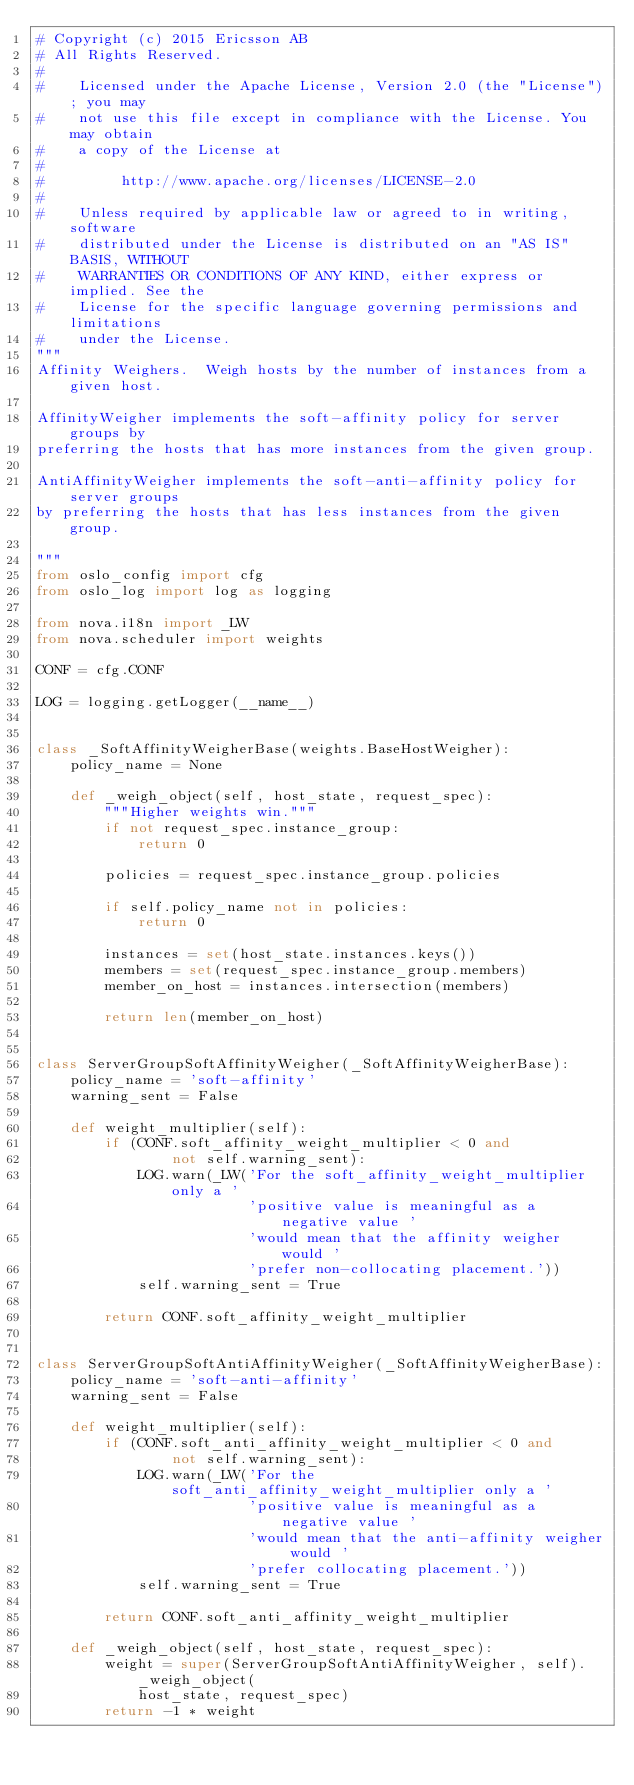<code> <loc_0><loc_0><loc_500><loc_500><_Python_># Copyright (c) 2015 Ericsson AB
# All Rights Reserved.
#
#    Licensed under the Apache License, Version 2.0 (the "License"); you may
#    not use this file except in compliance with the License. You may obtain
#    a copy of the License at
#
#         http://www.apache.org/licenses/LICENSE-2.0
#
#    Unless required by applicable law or agreed to in writing, software
#    distributed under the License is distributed on an "AS IS" BASIS, WITHOUT
#    WARRANTIES OR CONDITIONS OF ANY KIND, either express or implied. See the
#    License for the specific language governing permissions and limitations
#    under the License.
"""
Affinity Weighers.  Weigh hosts by the number of instances from a given host.

AffinityWeigher implements the soft-affinity policy for server groups by
preferring the hosts that has more instances from the given group.

AntiAffinityWeigher implements the soft-anti-affinity policy for server groups
by preferring the hosts that has less instances from the given group.

"""
from oslo_config import cfg
from oslo_log import log as logging

from nova.i18n import _LW
from nova.scheduler import weights

CONF = cfg.CONF

LOG = logging.getLogger(__name__)


class _SoftAffinityWeigherBase(weights.BaseHostWeigher):
    policy_name = None

    def _weigh_object(self, host_state, request_spec):
        """Higher weights win."""
        if not request_spec.instance_group:
            return 0

        policies = request_spec.instance_group.policies

        if self.policy_name not in policies:
            return 0

        instances = set(host_state.instances.keys())
        members = set(request_spec.instance_group.members)
        member_on_host = instances.intersection(members)

        return len(member_on_host)


class ServerGroupSoftAffinityWeigher(_SoftAffinityWeigherBase):
    policy_name = 'soft-affinity'
    warning_sent = False

    def weight_multiplier(self):
        if (CONF.soft_affinity_weight_multiplier < 0 and
                not self.warning_sent):
            LOG.warn(_LW('For the soft_affinity_weight_multiplier only a '
                         'positive value is meaningful as a negative value '
                         'would mean that the affinity weigher would '
                         'prefer non-collocating placement.'))
            self.warning_sent = True

        return CONF.soft_affinity_weight_multiplier


class ServerGroupSoftAntiAffinityWeigher(_SoftAffinityWeigherBase):
    policy_name = 'soft-anti-affinity'
    warning_sent = False

    def weight_multiplier(self):
        if (CONF.soft_anti_affinity_weight_multiplier < 0 and
                not self.warning_sent):
            LOG.warn(_LW('For the soft_anti_affinity_weight_multiplier only a '
                         'positive value is meaningful as a negative value '
                         'would mean that the anti-affinity weigher would '
                         'prefer collocating placement.'))
            self.warning_sent = True

        return CONF.soft_anti_affinity_weight_multiplier

    def _weigh_object(self, host_state, request_spec):
        weight = super(ServerGroupSoftAntiAffinityWeigher, self)._weigh_object(
            host_state, request_spec)
        return -1 * weight
</code> 